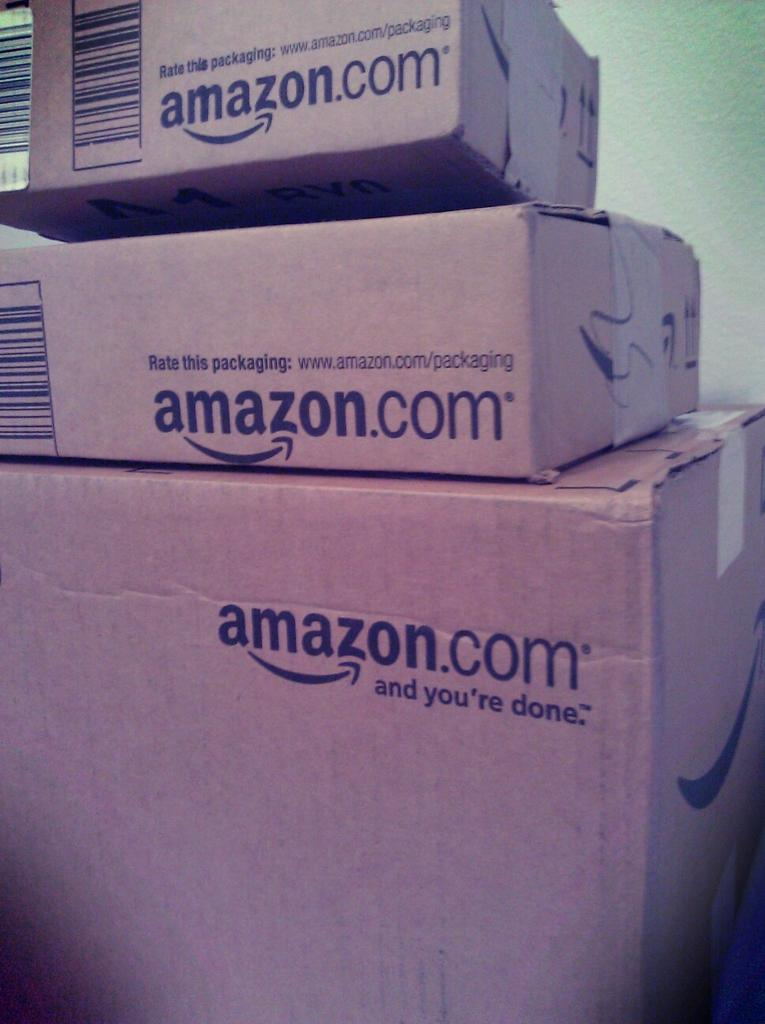<image>
Summarize the visual content of the image. A stack of boxes bearing the name "amazon.com" on them. 